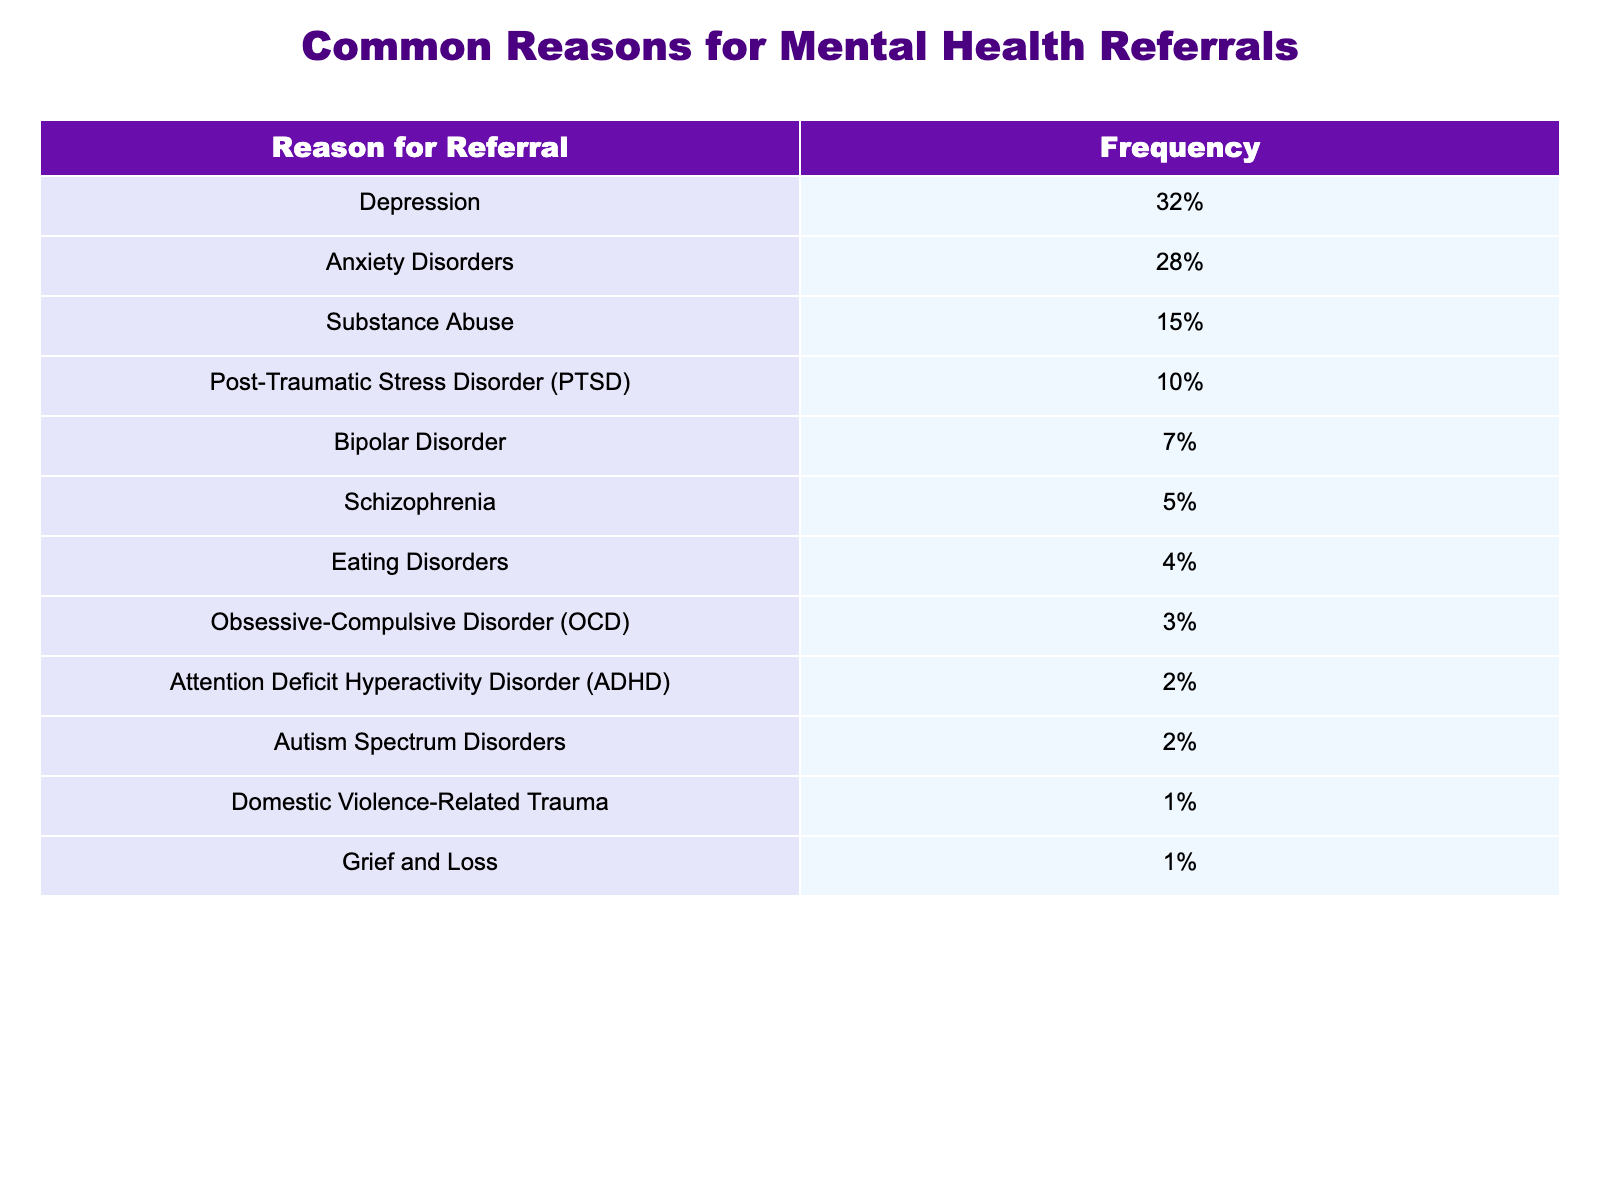What is the most common reason for mental health referrals? The table shows that the most common reason for mental health referrals is Depression, which has a frequency of 32%.
Answer: Depression What percentage of referrals are due to Anxiety Disorders? The table clearly indicates that Anxiety Disorders account for 28% of the referrals.
Answer: 28% How many reasons for referrals have a frequency of 5% or less? By examining the table, there are three reasons with 5% or less frequency: Schizophrenia (5%), Eating Disorders (4%), and Obsessive-Compulsive Disorder (3%).
Answer: 3 What is the difference in frequency between Depression and Substance Abuse referrals? The frequency of Depression is 32%, and Substance Abuse is 15%. The difference is 32% - 15% = 17%.
Answer: 17% Is the frequency of Bipolar Disorder referrals higher than that of Autism Spectrum Disorders? According to the table, Bipolar Disorder has a frequency of 7%, while Autism Spectrum Disorders have a frequency of 2%. Since 7% > 2%, the statement is true.
Answer: Yes What is the combined frequency of referrals for Eating Disorders and Obsessive-Compulsive Disorder (OCD)? The frequency of Eating Disorders is 4% and for OCD is 3%. Adding these together gives 4% + 3% = 7%.
Answer: 7% How does the frequency of referrals for PTSD compare to that for Substance Abuse? PTSD accounts for 10% of referrals while Substance Abuse accounts for 15%. Thus, Substance Abuse frequency is higher by 15% - 10% = 5%.
Answer: Substance Abuse is higher by 5% If the total number of referrals is 100 (considering percentages), how many referrals are for Depression? The percentage for Depression is 32%. Therefore, if the total is 100, then the number of referrals for Depression is 32% of 100, which is 32.
Answer: 32 What percentage of referrals fall under Domestic Violence-Related Trauma? The table states that Domestic Violence-Related Trauma accounts for 1% of referrals.
Answer: 1% Which condition has the lowest frequency of referrals, and what is that frequency? The condition with the lowest frequency is Domestic Violence-Related Trauma, with a frequency of 1%.
Answer: Domestic Violence-Related Trauma, 1% 